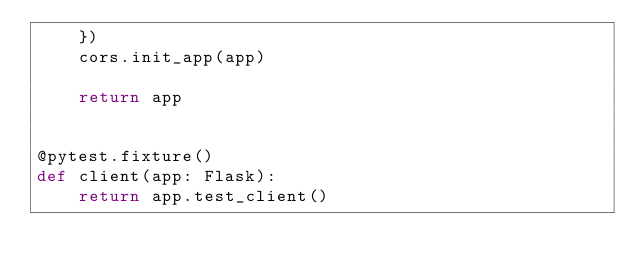<code> <loc_0><loc_0><loc_500><loc_500><_Python_>    })
    cors.init_app(app)

    return app


@pytest.fixture()
def client(app: Flask):
    return app.test_client()
</code> 